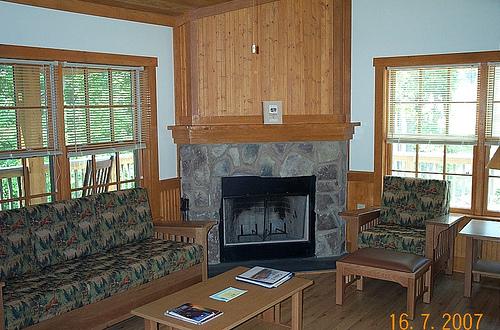Does this room have natural light?
Be succinct. Yes. What material is used most in the room?
Give a very brief answer. Wood. Is anyone sitting in this room?
Keep it brief. No. 